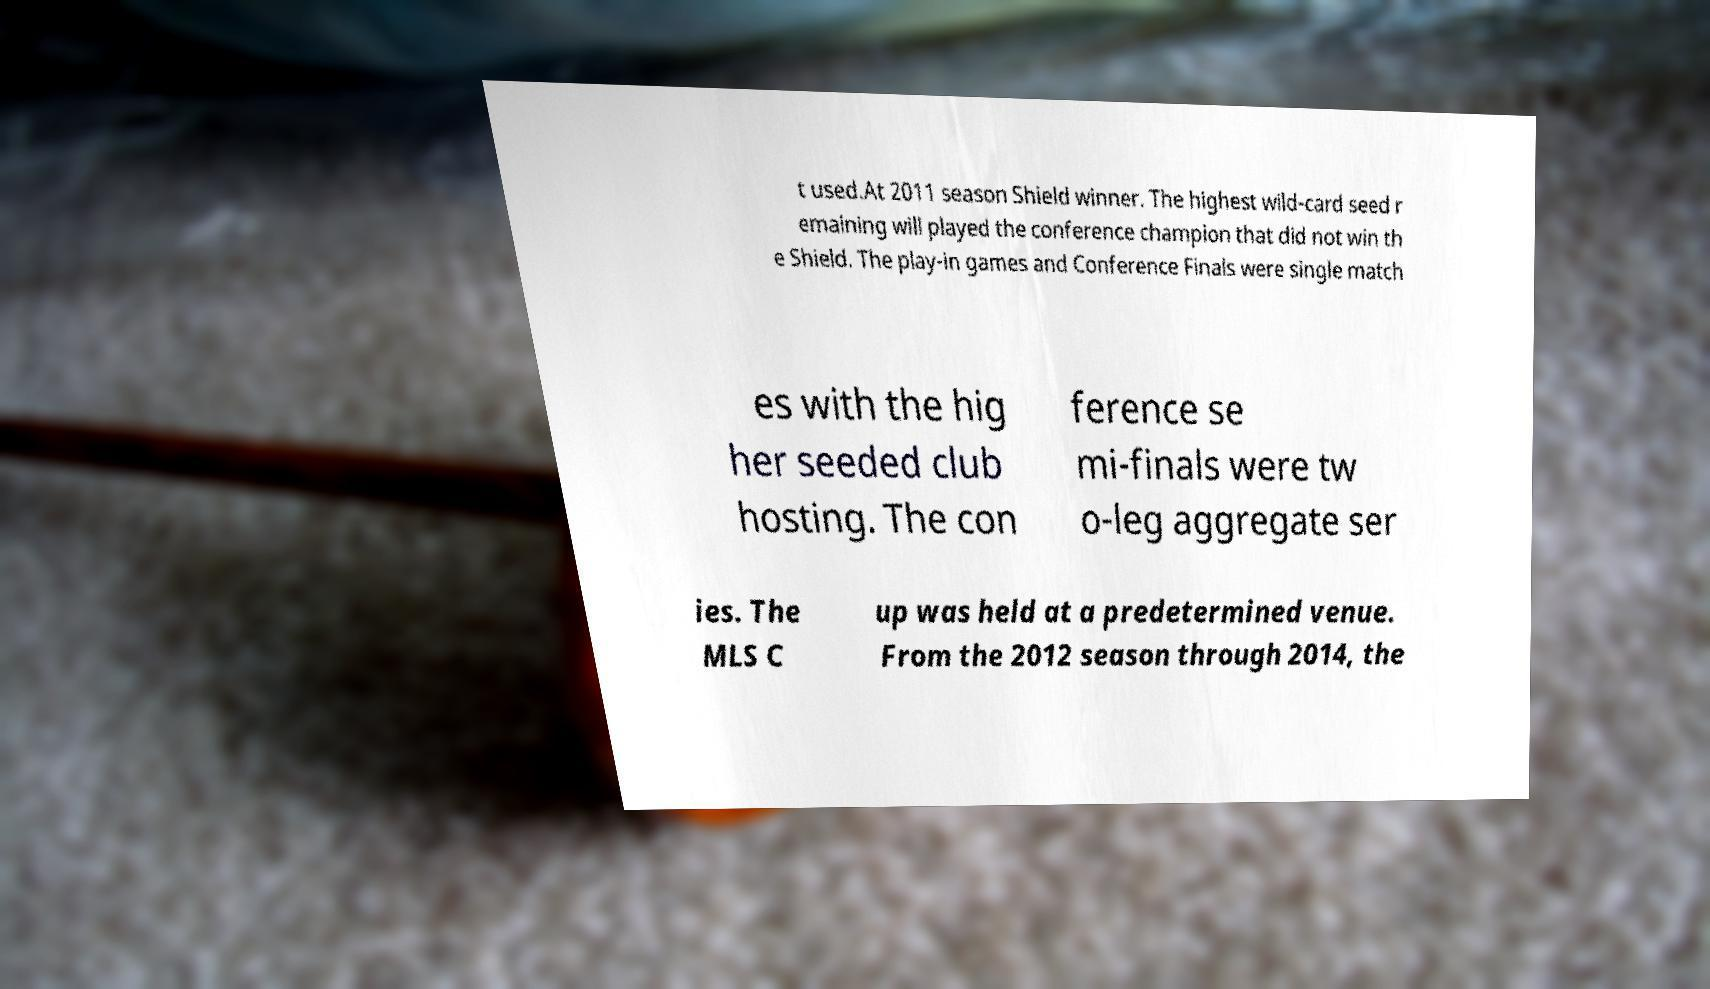There's text embedded in this image that I need extracted. Can you transcribe it verbatim? t used.At 2011 season Shield winner. The highest wild-card seed r emaining will played the conference champion that did not win th e Shield. The play-in games and Conference Finals were single match es with the hig her seeded club hosting. The con ference se mi-finals were tw o-leg aggregate ser ies. The MLS C up was held at a predetermined venue. From the 2012 season through 2014, the 